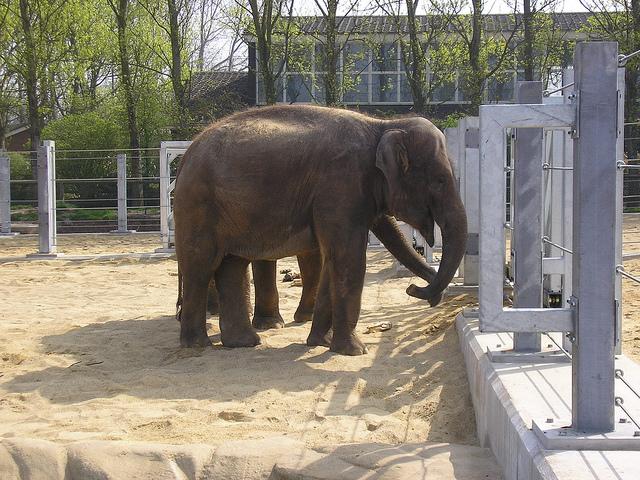Are these in the wild?
Concise answer only. No. Where is this scene?
Be succinct. Zoo. What are these animals?
Concise answer only. Elephants. How many animals can be seen?
Write a very short answer. 2. 